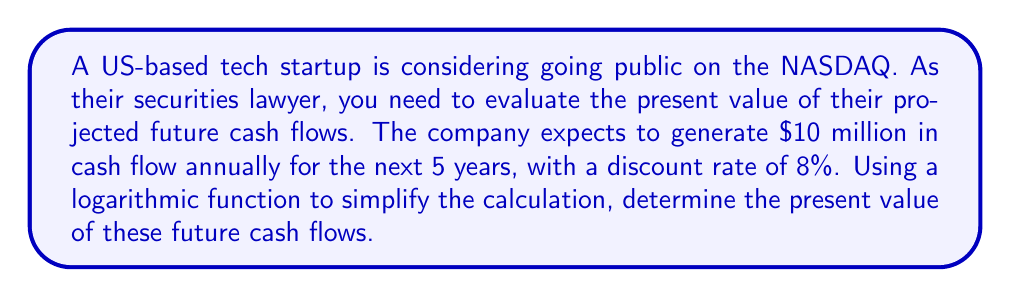Give your solution to this math problem. To solve this problem, we'll use the present value formula for an annuity and simplify it using logarithmic functions:

1) The general formula for the present value of an annuity is:

   $$PV = C \cdot \frac{1 - (1+r)^{-n}}{r}$$

   Where:
   $PV$ = Present Value
   $C$ = Cash flow per period
   $r$ = Discount rate
   $n$ = Number of periods

2) Given:
   $C = \$10$ million
   $r = 8\% = 0.08$
   $n = 5$ years

3) Substituting these values:

   $$PV = 10 \cdot \frac{1 - (1+0.08)^{-5}}{0.08}$$

4) To simplify this using logarithms, we can rewrite $(1+r)^{-n}$ as $e^{-n \cdot \ln(1+r)}$:

   $$PV = 10 \cdot \frac{1 - e^{-5 \cdot \ln(1.08)}}{0.08}$$

5) Calculate $\ln(1.08) \approx 0.0770$

6) Simplify:

   $$PV = 10 \cdot \frac{1 - e^{-5 \cdot 0.0770}}{0.08}$$

7) Calculate $e^{-5 \cdot 0.0770} \approx 0.6780$

8) Substitute:

   $$PV = 10 \cdot \frac{1 - 0.6780}{0.08} = 10 \cdot \frac{0.3220}{0.08} = 10 \cdot 4.025 = 40.25$$

Therefore, the present value of the future cash flows is $40.25 million.
Answer: $40.25 million 